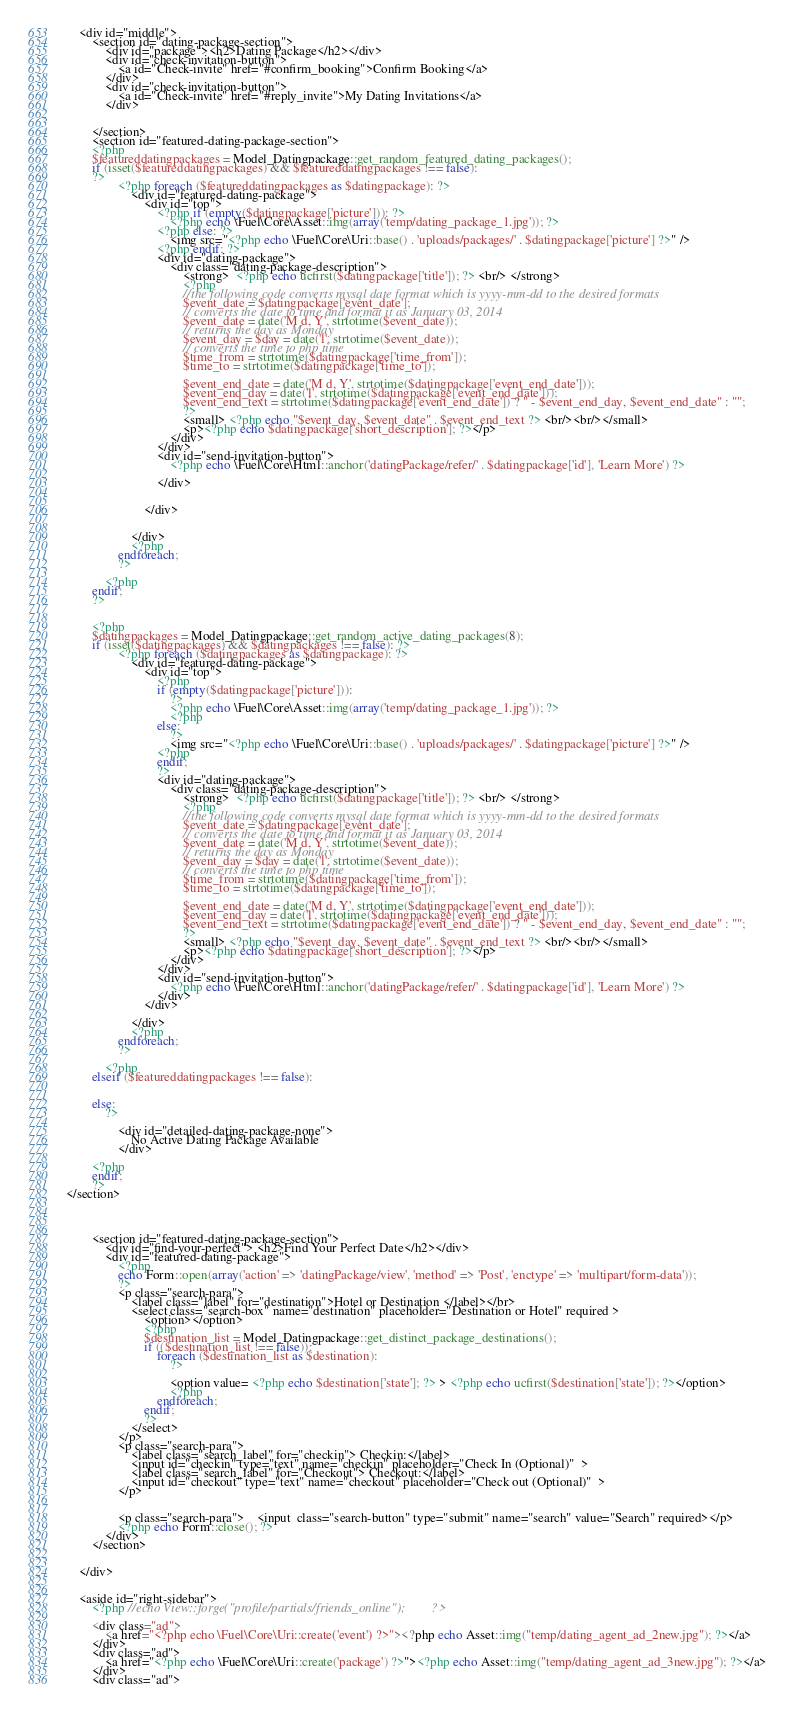Convert code to text. <code><loc_0><loc_0><loc_500><loc_500><_PHP_>    <div id="middle">
        <section id="dating-package-section">
            <div id="package"><h2>Dating Package</h2></div>
            <div id="check-invitation-button">
                <a id="Check-invite" href="#confirm_booking">Confirm Booking</a>
            </div>
            <div id="check-invitation-button">
                <a id="Check-invite" href="#reply_invite">My Dating Invitations</a>
            </div>


        </section>
        <section id="featured-dating-package-section">
        <?php
        $featureddatingpackages = Model_Datingpackage::get_random_featured_dating_packages();
        if (isset($featureddatingpackages) && $featureddatingpackages !== false):
        ?>
                <?php foreach ($featureddatingpackages as $datingpackage): ?>
                    <div id="featured-dating-package">
                        <div id="top">
                            <?php if (empty($datingpackage['picture'])): ?>
                                <?php echo \Fuel\Core\Asset::img(array('temp/dating_package_1.jpg')); ?>
                            <?php else: ?>
                                <img src="<?php echo \Fuel\Core\Uri::base() . 'uploads/packages/' . $datingpackage['picture'] ?>" />
                            <?php endif; ?>
                            <div id="dating-package">
                                <div class="dating-package-description">
                                    <strong>  <?php echo ucfirst($datingpackage['title']); ?> <br/> </strong>
                                    <?php
                                    //the following code converts mysql date format which is yyyy-mm-dd to the desired formats
                                    $event_date = $datingpackage['event_date'];
                                    // converts the date to time and format it as January 03, 2014
                                    $event_date = date('M d, Y', strtotime($event_date));
                                    // returns the day as Monday
                                    $event_day = $day = date('l', strtotime($event_date));
                                    // converts the time to php time
                                    $time_from = strtotime($datingpackage['time_from']);
                                    $time_to = strtotime($datingpackage['time_to']);

                                    $event_end_date = date('M d, Y', strtotime($datingpackage['event_end_date']));
                                    $event_end_day = date('l', strtotime($datingpackage['event_end_date']));
                                    $event_end_text = strtotime($datingpackage['event_end_date']) ? " - $event_end_day, $event_end_date" : "";
                                    ?>
                                    <small> <?php echo "$event_day, $event_date" . $event_end_text ?> <br/><br/></small>
                                    <p><?php echo $datingpackage['short_description']; ?></p>
                                </div>
                            </div>
                            <div id="send-invitation-button">
                                <?php echo \Fuel\Core\Html::anchor('datingPackage/refer/' . $datingpackage['id'], 'Learn More') ?>

                            </div>


                        </div>


                    </div>
                    <?php
                endforeach;
                ?>
            
            <?php
        endif;
        ?>


        <?php
        $datingpackages = Model_Datingpackage::get_random_active_dating_packages(8);
        if (isset($datingpackages) && $datingpackages !== false): ?>
                <?php foreach ($datingpackages as $datingpackage): ?>
                    <div id="featured-dating-package">
                        <div id="top">
                            <?php
                            if (empty($datingpackage['picture'])):
                                ?>
                                <?php echo \Fuel\Core\Asset::img(array('temp/dating_package_1.jpg')); ?>
                                <?php
                            else:
                                ?>
                                <img src="<?php echo \Fuel\Core\Uri::base() . 'uploads/packages/' . $datingpackage['picture'] ?>" />
                            <?php
                            endif;
                            ?>
                            <div id="dating-package">
                                <div class="dating-package-description">
                                    <strong>  <?php echo ucfirst($datingpackage['title']); ?> <br/> </strong>
                                    <?php
                                    //the following code converts mysql date format which is yyyy-mm-dd to the desired formats
                                    $event_date = $datingpackage['event_date'];
                                    // converts the date to time and format it as January 03, 2014
                                    $event_date = date('M d, Y', strtotime($event_date));
                                    // returns the day as Monday
                                    $event_day = $day = date('l', strtotime($event_date));
                                    // converts the time to php time
                                    $time_from = strtotime($datingpackage['time_from']);
                                    $time_to = strtotime($datingpackage['time_to']);

                                    $event_end_date = date('M d, Y', strtotime($datingpackage['event_end_date']));
                                    $event_end_day = date('l', strtotime($datingpackage['event_end_date']));
                                    $event_end_text = strtotime($datingpackage['event_end_date']) ? " - $event_end_day, $event_end_date" : "";
                                    ?>
                                    <small> <?php echo "$event_day, $event_date" . $event_end_text ?> <br/><br/></small>
                                    <p><?php echo $datingpackage['short_description']; ?></p>
                                </div>
                            </div>
                            <div id="send-invitation-button">
                                <?php echo \Fuel\Core\Html::anchor('datingPackage/refer/' . $datingpackage['id'], 'Learn More') ?>
                            </div>
                        </div>

                    </div>
                    <?php
                endforeach;
                ?>
            
            <?php
        elseif ($featureddatingpackages !== false):


        else:
            ?>
           
                <div id="detailed-dating-package-none">
                    No Active Dating Package Available
                </div>
            
        <?php
        endif;
        ?>
</section>




        <section id="featured-dating-package-section">
            <div id="find-your-perfect"> <h2>Find Your Perfect Date</h2></div>
            <div id="featured-dating-package">
                <?php
                echo Form::open(array('action' => 'datingPackage/view', 'method' => 'Post', 'enctype' => 'multipart/form-data'));
                ?> 
                <p class="search-para">
                    <label class="label" for="destination">Hotel or Destination </label></br>
                    <select class="search-box" name="destination" placeholder="Destination or Hotel" required >
                        <option></option>
                        <?php
                        $destination_list = Model_Datingpackage::get_distinct_package_destinations();
                        if (($destination_list !== false)):
                            foreach ($destination_list as $destination):
                                ?>

                                <option value= <?php echo $destination['state']; ?> > <?php echo ucfirst($destination['state']); ?></option>
                                <?php
                            endforeach;
                        endif;
                        ?>
                    </select>
                </p>
                <p class="search-para">
                    <label class="search_label" for="checkin"> Checkin:</label>
                    <input id="checkin" type="text" name="checkin" placeholder="Check In (Optional)"  >
                    <label class="search_label" for="Checkout"> Checkout:</label>
                    <input id="checkout" type="text" name="checkout" placeholder="Check out (Optional)"  >
                </p>


                <p class="search-para">    <input  class="search-button" type="submit" name="search" value="Search" required></p>
                <?php echo Form::close(); ?>
            </div>
        </section>


    </div>


    <aside id="right-sidebar">
        <?php //echo View::forge("profile/partials/friends_online");        ?>

        <div class="ad">
            <a href="<?php echo \Fuel\Core\Uri::create('event') ?>"><?php echo Asset::img("temp/dating_agent_ad_2new.jpg"); ?></a>
        </div>
        <div class="ad">
            <a href="<?php echo \Fuel\Core\Uri::create('package') ?>"><?php echo Asset::img("temp/dating_agent_ad_3new.jpg"); ?></a>
        </div>
        <div class="ad"></code> 